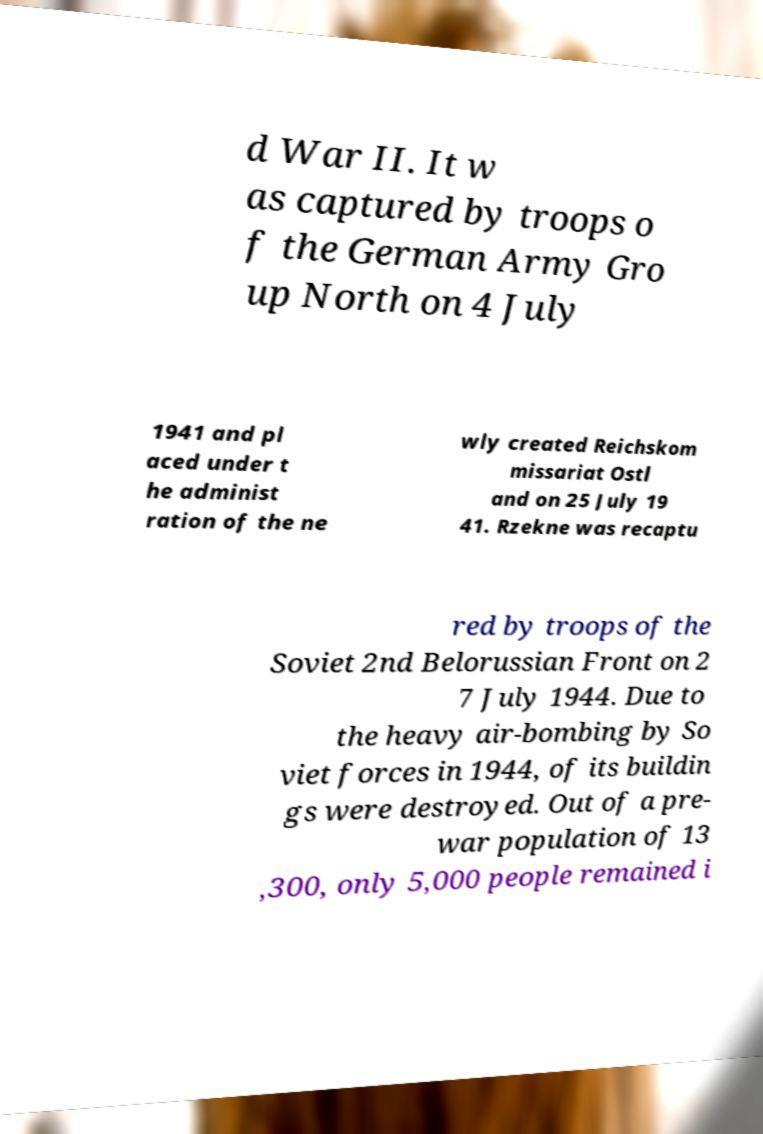There's text embedded in this image that I need extracted. Can you transcribe it verbatim? d War II. It w as captured by troops o f the German Army Gro up North on 4 July 1941 and pl aced under t he administ ration of the ne wly created Reichskom missariat Ostl and on 25 July 19 41. Rzekne was recaptu red by troops of the Soviet 2nd Belorussian Front on 2 7 July 1944. Due to the heavy air-bombing by So viet forces in 1944, of its buildin gs were destroyed. Out of a pre- war population of 13 ,300, only 5,000 people remained i 